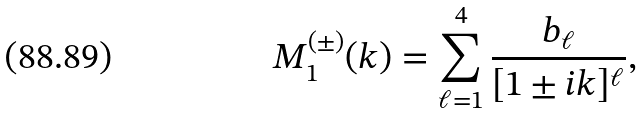Convert formula to latex. <formula><loc_0><loc_0><loc_500><loc_500>M _ { 1 } ^ { ( \pm ) } ( k ) = \sum _ { \ell = 1 } ^ { 4 } \frac { b _ { \ell } } { [ 1 \pm i k ] ^ { \ell } } ,</formula> 